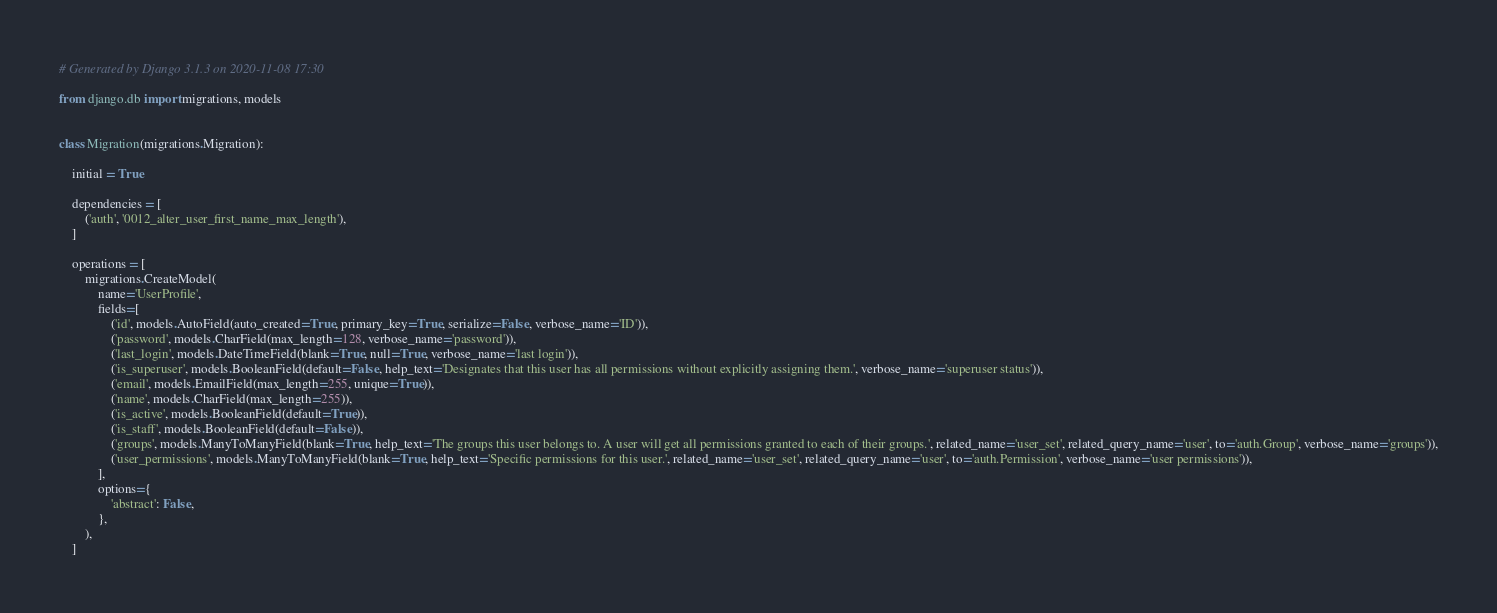<code> <loc_0><loc_0><loc_500><loc_500><_Python_># Generated by Django 3.1.3 on 2020-11-08 17:30

from django.db import migrations, models


class Migration(migrations.Migration):

    initial = True

    dependencies = [
        ('auth', '0012_alter_user_first_name_max_length'),
    ]

    operations = [
        migrations.CreateModel(
            name='UserProfile',
            fields=[
                ('id', models.AutoField(auto_created=True, primary_key=True, serialize=False, verbose_name='ID')),
                ('password', models.CharField(max_length=128, verbose_name='password')),
                ('last_login', models.DateTimeField(blank=True, null=True, verbose_name='last login')),
                ('is_superuser', models.BooleanField(default=False, help_text='Designates that this user has all permissions without explicitly assigning them.', verbose_name='superuser status')),
                ('email', models.EmailField(max_length=255, unique=True)),
                ('name', models.CharField(max_length=255)),
                ('is_active', models.BooleanField(default=True)),
                ('is_staff', models.BooleanField(default=False)),
                ('groups', models.ManyToManyField(blank=True, help_text='The groups this user belongs to. A user will get all permissions granted to each of their groups.', related_name='user_set', related_query_name='user', to='auth.Group', verbose_name='groups')),
                ('user_permissions', models.ManyToManyField(blank=True, help_text='Specific permissions for this user.', related_name='user_set', related_query_name='user', to='auth.Permission', verbose_name='user permissions')),
            ],
            options={
                'abstract': False,
            },
        ),
    ]
</code> 